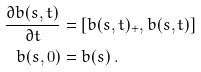<formula> <loc_0><loc_0><loc_500><loc_500>\frac { \partial b ( s , t ) } { \partial t } & = [ b ( s , t ) _ { + } , b ( s , t ) ] \\ b ( s , 0 ) & = b ( s ) \ .</formula> 